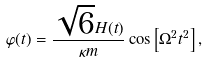<formula> <loc_0><loc_0><loc_500><loc_500>\varphi ( t ) = \frac { \sqrt { 6 } H ( t ) } { \kappa m } \cos \left [ \Omega ^ { 2 } t ^ { 2 } \right ] ,</formula> 